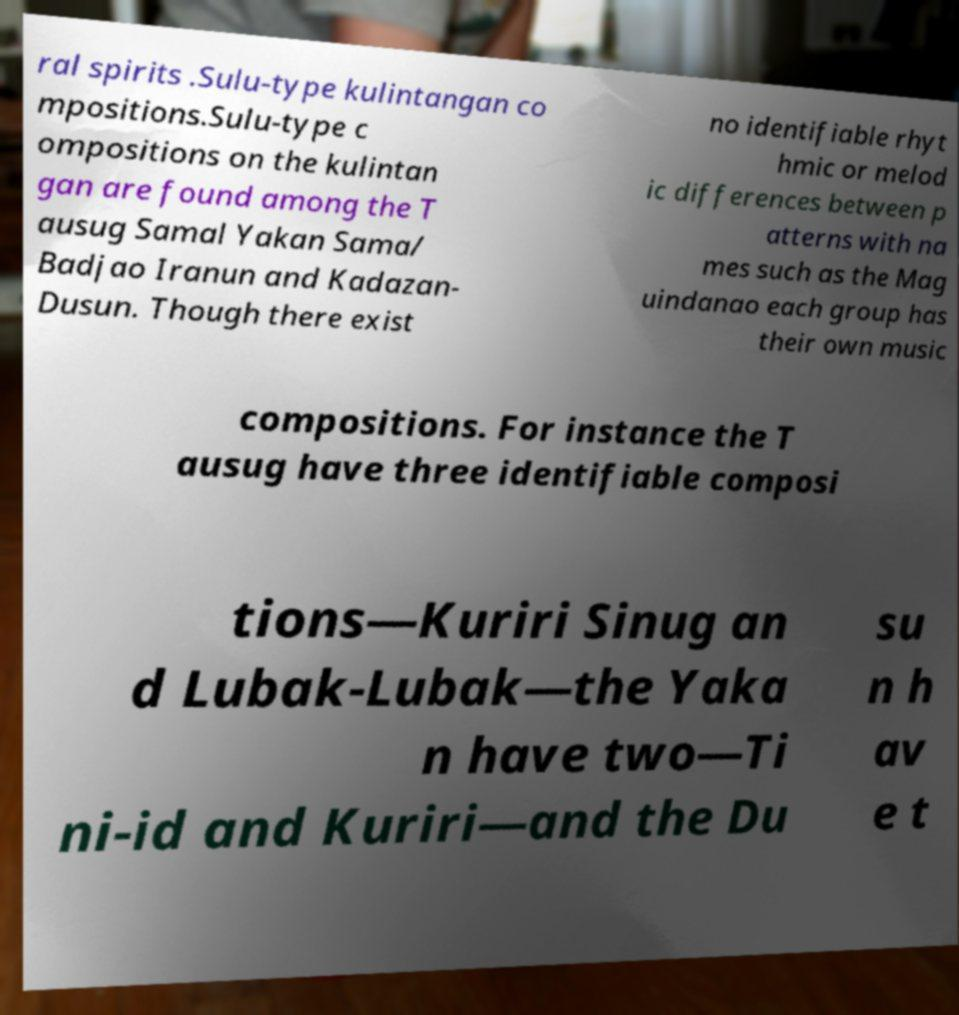Could you assist in decoding the text presented in this image and type it out clearly? ral spirits .Sulu-type kulintangan co mpositions.Sulu-type c ompositions on the kulintan gan are found among the T ausug Samal Yakan Sama/ Badjao Iranun and Kadazan- Dusun. Though there exist no identifiable rhyt hmic or melod ic differences between p atterns with na mes such as the Mag uindanao each group has their own music compositions. For instance the T ausug have three identifiable composi tions—Kuriri Sinug an d Lubak-Lubak—the Yaka n have two—Ti ni-id and Kuriri—and the Du su n h av e t 